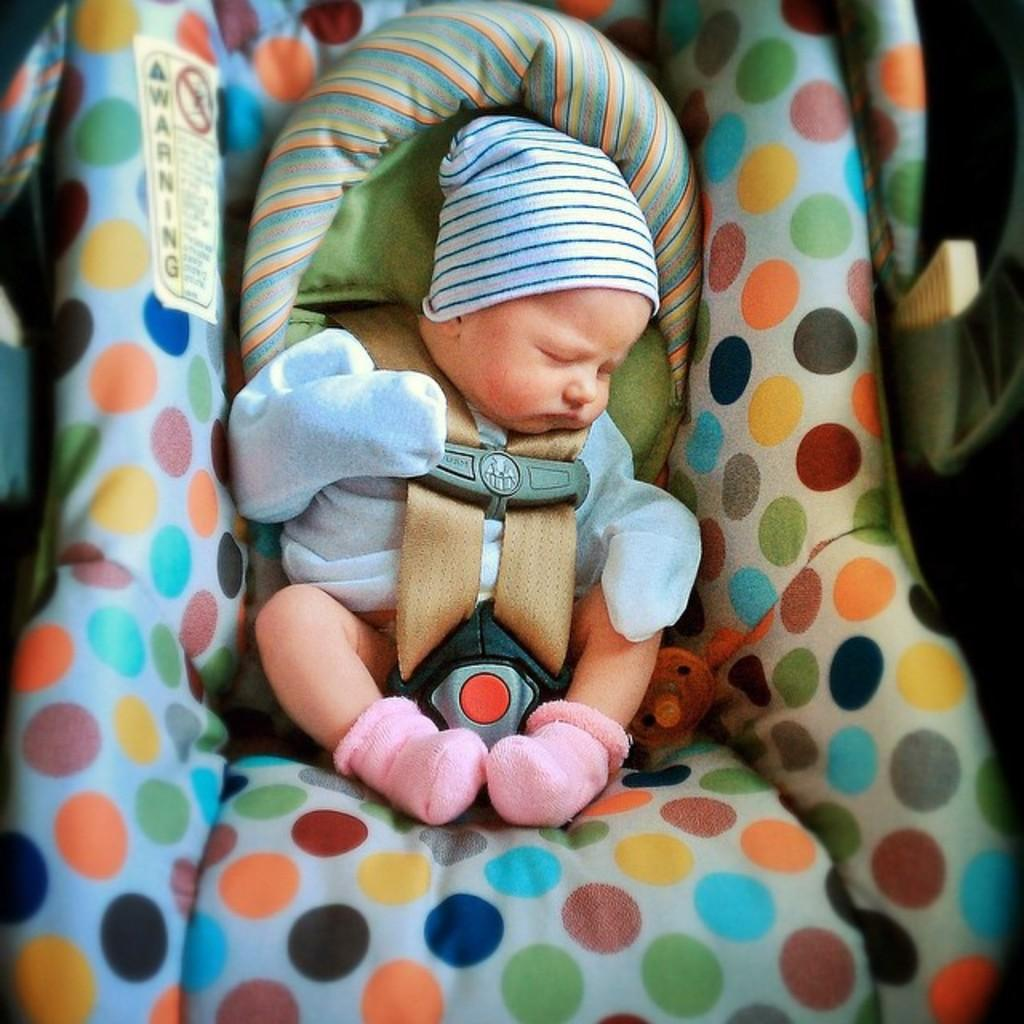What is the main subject of the image? There is a cute little baby in the image. What is the baby doing in the image? The baby is sleeping. What type of clothing is the baby wearing? The baby is wearing a baby cloth. What type of headwear is the baby wearing? The baby is wearing a cap. What type of footwear is the baby wearing? The baby is wearing socks. What type of receipt is the baby holding in the image? There is no receipt present in the image; the baby is sleeping and wearing clothing items. What type of dog is visible in the image? There is no dog present in the image; the image only features a baby. 